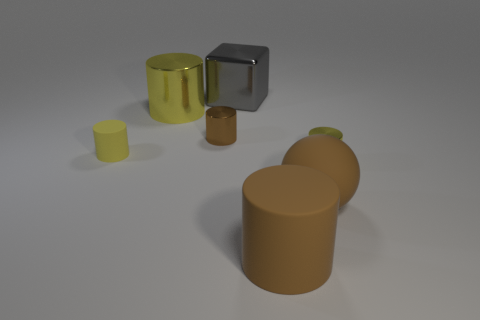How many cylinders are the same color as the ball?
Your answer should be very brief. 2. What number of other things are the same color as the big rubber sphere?
Make the answer very short. 2. What number of things are both behind the matte ball and on the right side of the yellow rubber cylinder?
Give a very brief answer. 4. Is there any other thing that is the same size as the block?
Your response must be concise. Yes. Are there more yellow metal cylinders that are on the left side of the big brown rubber cylinder than cylinders right of the yellow rubber thing?
Provide a succinct answer. No. There is a big cylinder right of the tiny brown metallic object; what is its material?
Make the answer very short. Rubber. There is a yellow rubber object; does it have the same shape as the small metal thing on the left side of the big brown ball?
Ensure brevity in your answer.  Yes. There is a yellow metallic object that is to the right of the tiny brown metal object that is on the right side of the tiny yellow rubber cylinder; what number of gray objects are left of it?
Provide a succinct answer. 1. There is a large metallic object that is the same shape as the small matte thing; what is its color?
Your response must be concise. Yellow. Is there any other thing that has the same shape as the small brown thing?
Provide a short and direct response. Yes. 